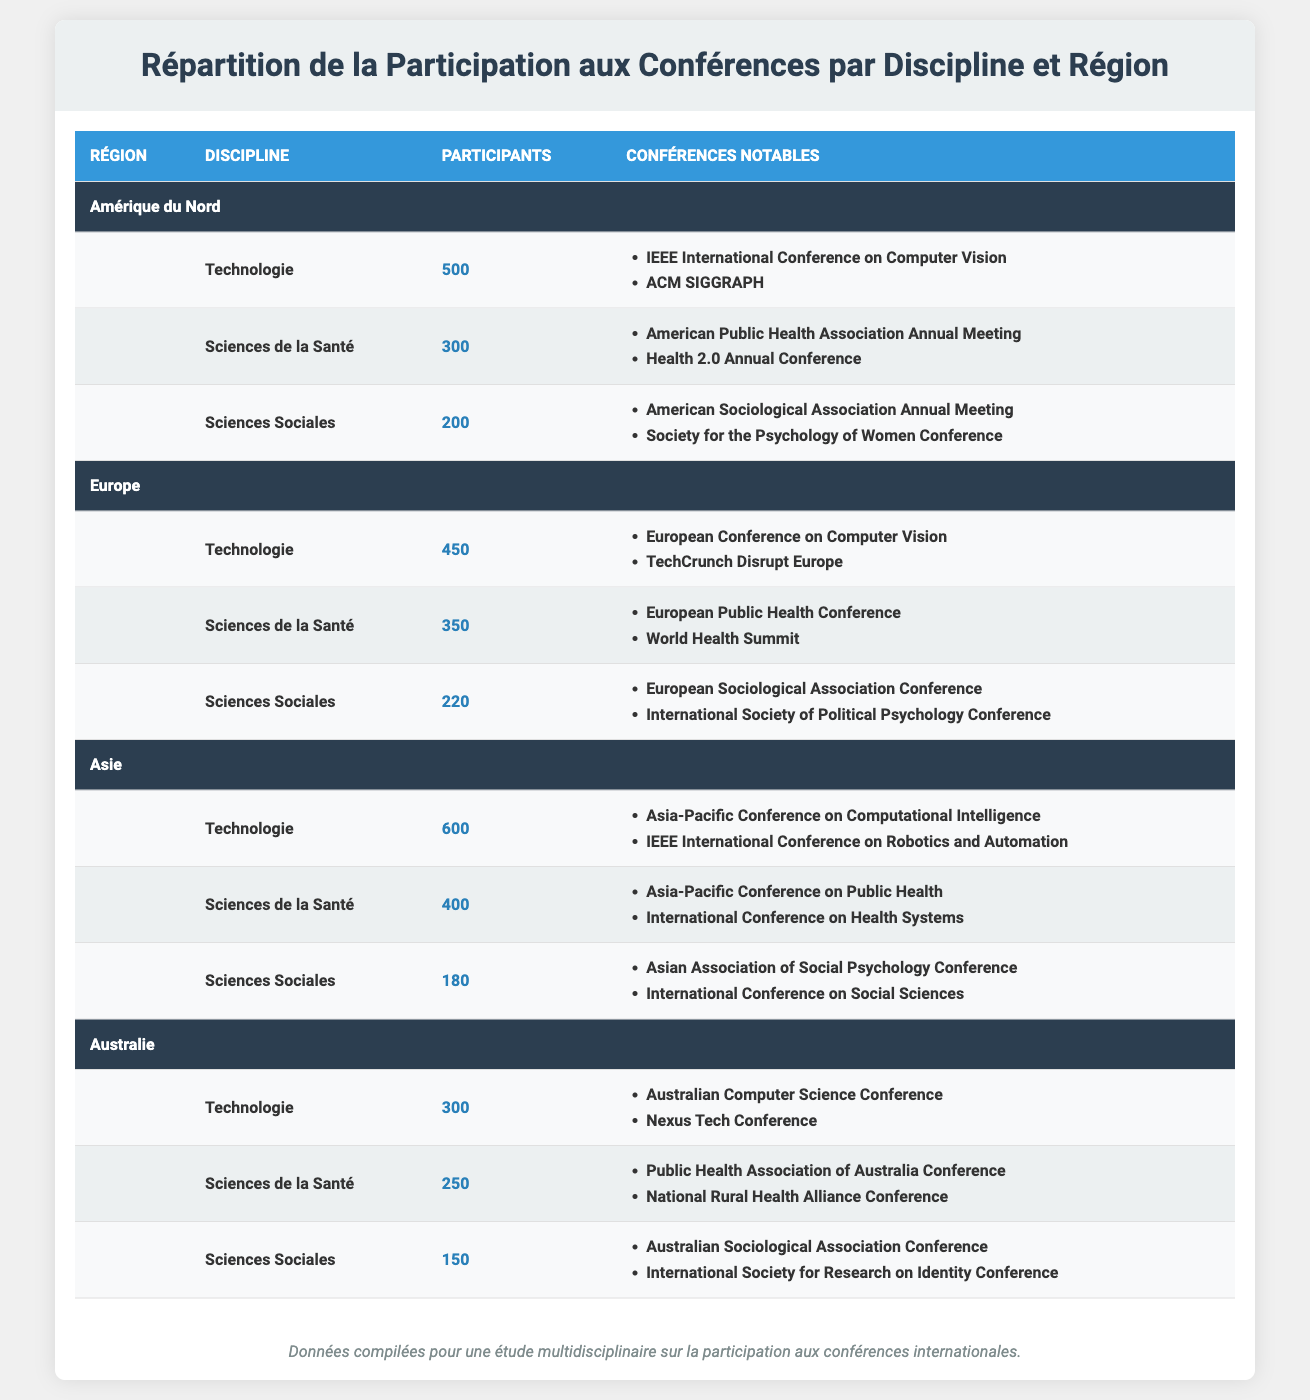What is the total number of attendees from North America across all disciplines? From the North America section, Technology has 500 attendees, Health Sciences has 300, and Social Sciences has 200. Adding these up gives 500 + 300 + 200 = 1000.
Answer: 1000 Which discipline had the highest number of attendees in Asia? The Asia section shows Technology with 600 attendees, Health Sciences with 400, and Social Sciences with 180. The maximum value among these is for Technology.
Answer: Technology Is the Health Sciences discipline more popular in Europe than in Australia? In Europe, Health Sciences has 350 attendees, while in Australia, it has 250. Since 350 is greater than 250, Health Sciences is indeed more popular in Europe.
Answer: Yes How many total attendees are there in the Social Sciences discipline across all regions? The total for Social Sciences is calculated by summing 200 (North America) + 220 (Europe) + 180 (Asia) + 150 (Australia), which equals 200 + 220 + 180 + 150 = 750.
Answer: 750 What region had the lowest attendance in the Technology discipline? In the Technology discipline, North America had 500 attendees, Europe had 450 attendees, Asia had 600 attendees, and Australia had 300 attendees. The minimum is from Australia with 300.
Answer: Australia Which region has the highest total attendance in the Health Sciences discipline? Summing attendees for Health Sciences: North America has 300, Europe has 350, Asia has 400, and Australia has 250. Asia has the highest with 400 attendees.
Answer: Asia What is the average number of attendees across all disciplines in North America? The total attendees in North America are 500 (Technology) + 300 (Health Sciences) + 200 (Social Sciences) = 1000. There are three disciplines, so the average is 1000 / 3 = approximately 333.33.
Answer: 333.33 Is the total number of Technology attendees across all regions greater than the total number of Social Sciences attendees? The total for Technology is 500 (North America) + 450 (Europe) + 600 (Asia) + 300 (Australia) = 1850. The total for Social Sciences is 750. Since 1850 is greater than 750, the statement is true.
Answer: Yes In how many notable conferences does the Health Sciences discipline participate in North America? There are two notable conferences listed for Health Sciences in North America: American Public Health Association Annual Meeting and Health 2.0 Annual Conference. Thus, Health Sciences in North America has 2 notable conferences.
Answer: 2 